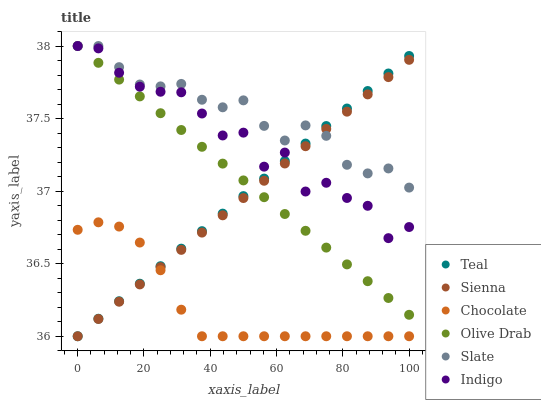Does Chocolate have the minimum area under the curve?
Answer yes or no. Yes. Does Slate have the maximum area under the curve?
Answer yes or no. Yes. Does Slate have the minimum area under the curve?
Answer yes or no. No. Does Chocolate have the maximum area under the curve?
Answer yes or no. No. Is Teal the smoothest?
Answer yes or no. Yes. Is Indigo the roughest?
Answer yes or no. Yes. Is Slate the smoothest?
Answer yes or no. No. Is Slate the roughest?
Answer yes or no. No. Does Chocolate have the lowest value?
Answer yes or no. Yes. Does Slate have the lowest value?
Answer yes or no. No. Does Olive Drab have the highest value?
Answer yes or no. Yes. Does Chocolate have the highest value?
Answer yes or no. No. Is Chocolate less than Olive Drab?
Answer yes or no. Yes. Is Slate greater than Chocolate?
Answer yes or no. Yes. Does Teal intersect Olive Drab?
Answer yes or no. Yes. Is Teal less than Olive Drab?
Answer yes or no. No. Is Teal greater than Olive Drab?
Answer yes or no. No. Does Chocolate intersect Olive Drab?
Answer yes or no. No. 